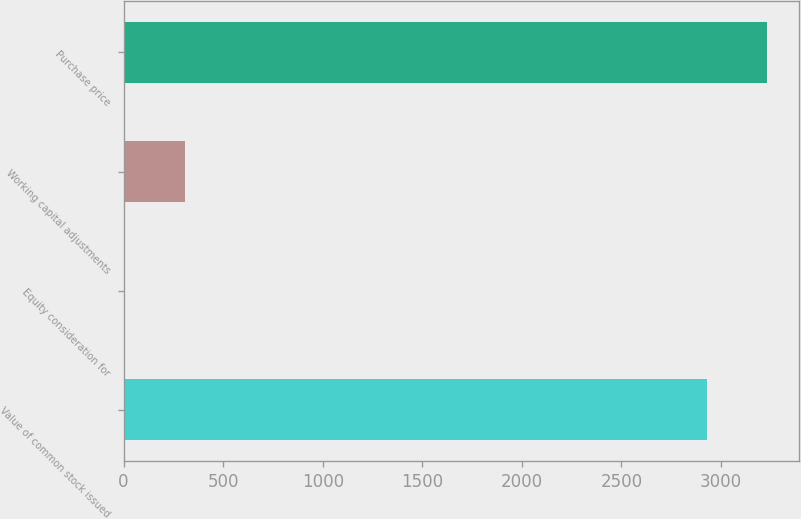<chart> <loc_0><loc_0><loc_500><loc_500><bar_chart><fcel>Value of common stock issued<fcel>Equity consideration for<fcel>Working capital adjustments<fcel>Purchase price<nl><fcel>2929<fcel>9<fcel>310<fcel>3230<nl></chart> 